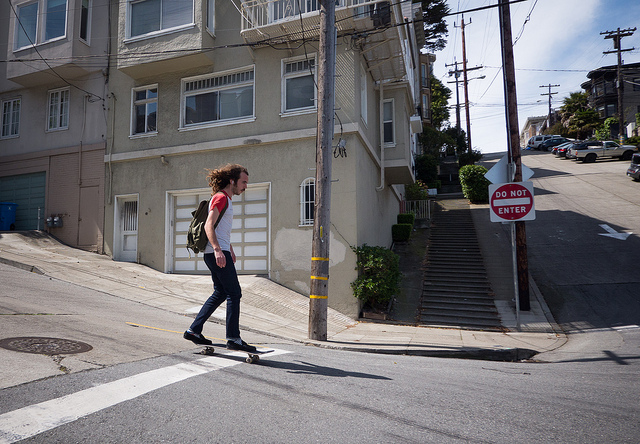Extract all visible text content from this image. DO NOT ENTER 